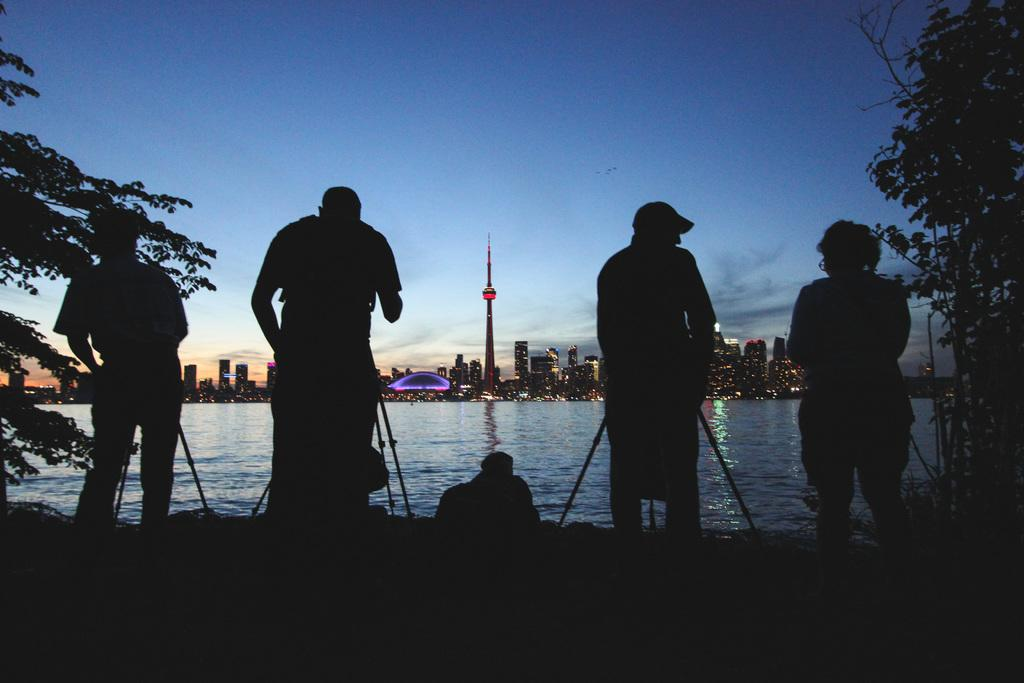Who or what is present in the image? There are persons in the image. What are the persons holding in the image? The persons are holding a camera. What is in front of the persons in the image? There is a tripod in front of the persons. What can be seen in the background of the image? There are buildings in the background of the image, and they are located near a lake. What is visible above the lake in the image? The sky is visible above the lake. What is the income of the persons in the image? There is no information about the income of the persons in the image. How hot is the camera in the image? The temperature of the camera is not mentioned in the image, and it cannot be determined from the image alone. 